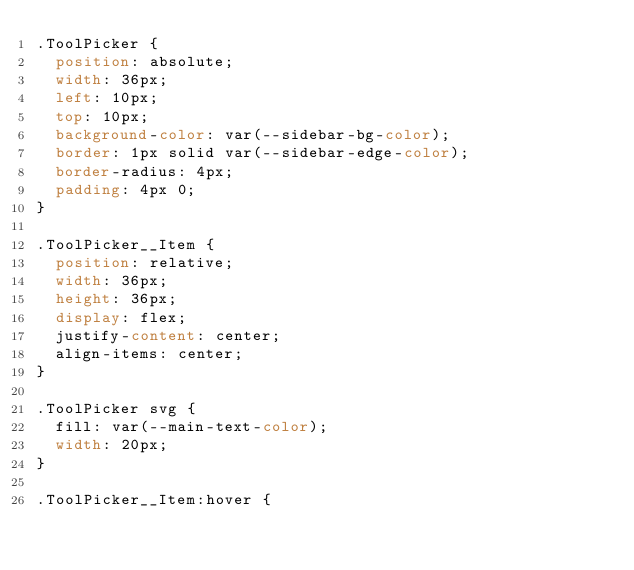<code> <loc_0><loc_0><loc_500><loc_500><_CSS_>.ToolPicker {
  position: absolute;
  width: 36px;
  left: 10px;
  top: 10px;
  background-color: var(--sidebar-bg-color);
  border: 1px solid var(--sidebar-edge-color);
  border-radius: 4px;
  padding: 4px 0;
}

.ToolPicker__Item {
  position: relative;
  width: 36px;
  height: 36px;
  display: flex;
  justify-content: center;
  align-items: center;
}

.ToolPicker svg {
  fill: var(--main-text-color);
  width: 20px;
}

.ToolPicker__Item:hover {</code> 